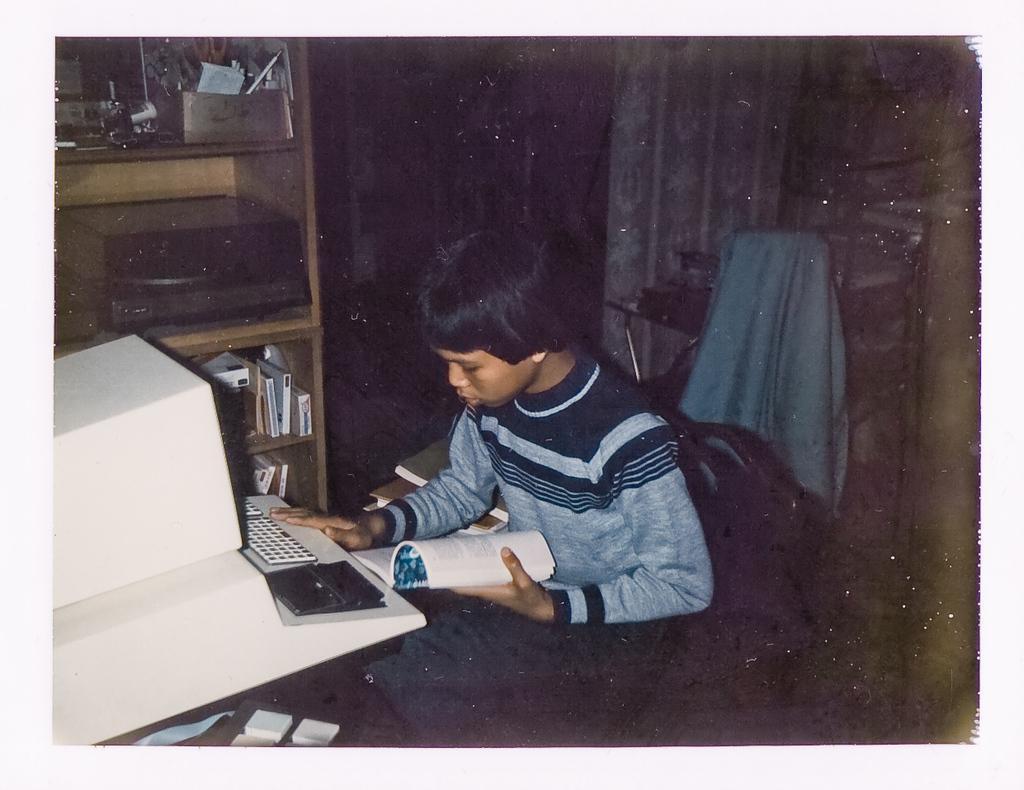In one or two sentences, can you explain what this image depicts? This picture is clicked inside the room. In the center there is a person wearing t-shirt, holding a book and sitting on the chair and we can see a keyboard and some other objects are placed on the top of the table. In the background we can see the curtains, chair, cloth and a wooden cabinet containing books and some other objects. 